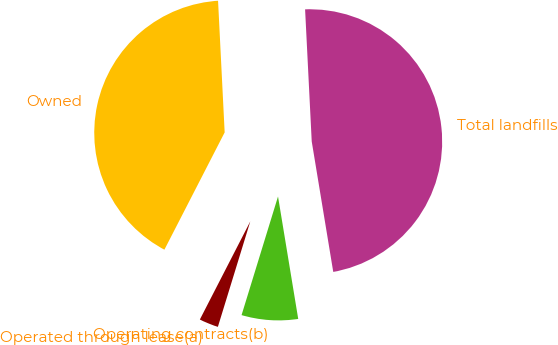<chart> <loc_0><loc_0><loc_500><loc_500><pie_chart><fcel>Owned<fcel>Operated through lease(a)<fcel>Operating contracts(b)<fcel>Total landfills<nl><fcel>41.65%<fcel>2.81%<fcel>7.35%<fcel>48.2%<nl></chart> 